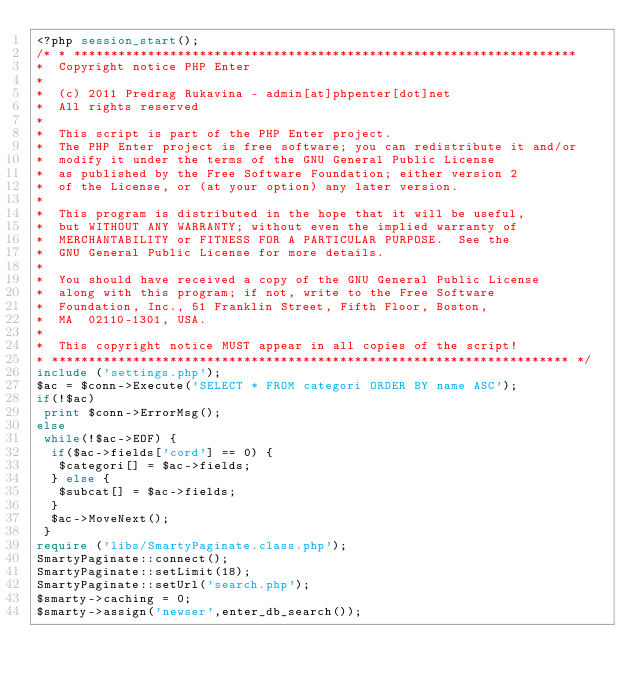<code> <loc_0><loc_0><loc_500><loc_500><_PHP_><?php session_start();
/* * ********************************************************************
*  Copyright notice PHP Enter
*
*  (c) 2011 Predrag Rukavina - admin[at]phpenter[dot]net
*  All rights reserved
*
*  This script is part of the PHP Enter project. 
*  The PHP Enter project is free software; you can redistribute it and/or
*  modify it under the terms of the GNU General Public License
*  as published by the Free Software Foundation; either version 2
*  of the License, or (at your option) any later version.
*
*  This program is distributed in the hope that it will be useful,
*  but WITHOUT ANY WARRANTY; without even the implied warranty of
*  MERCHANTABILITY or FITNESS FOR A PARTICULAR PURPOSE.  See the
*  GNU General Public License for more details.
*
*  You should have received a copy of the GNU General Public License
*  along with this program; if not, write to the Free Software
*  Foundation, Inc., 51 Franklin Street, Fifth Floor, Boston,
*  MA  02110-1301, USA.
*
*  This copyright notice MUST appear in all copies of the script!
* ********************************************************************** */
include ('settings.php');
$ac = $conn->Execute('SELECT * FROM categori ORDER BY name ASC');
if(!$ac)
 print $conn->ErrorMsg();
else
 while(!$ac->EOF) {
  if($ac->fields['cord'] == 0) {
   $categori[] = $ac->fields;
  } else {
   $subcat[] = $ac->fields;
  }
  $ac->MoveNext();
 }
require ('libs/SmartyPaginate.class.php');
SmartyPaginate::connect();
SmartyPaginate::setLimit(18);
SmartyPaginate::setUrl('search.php');
$smarty->caching = 0;
$smarty->assign('newser',enter_db_search());</code> 